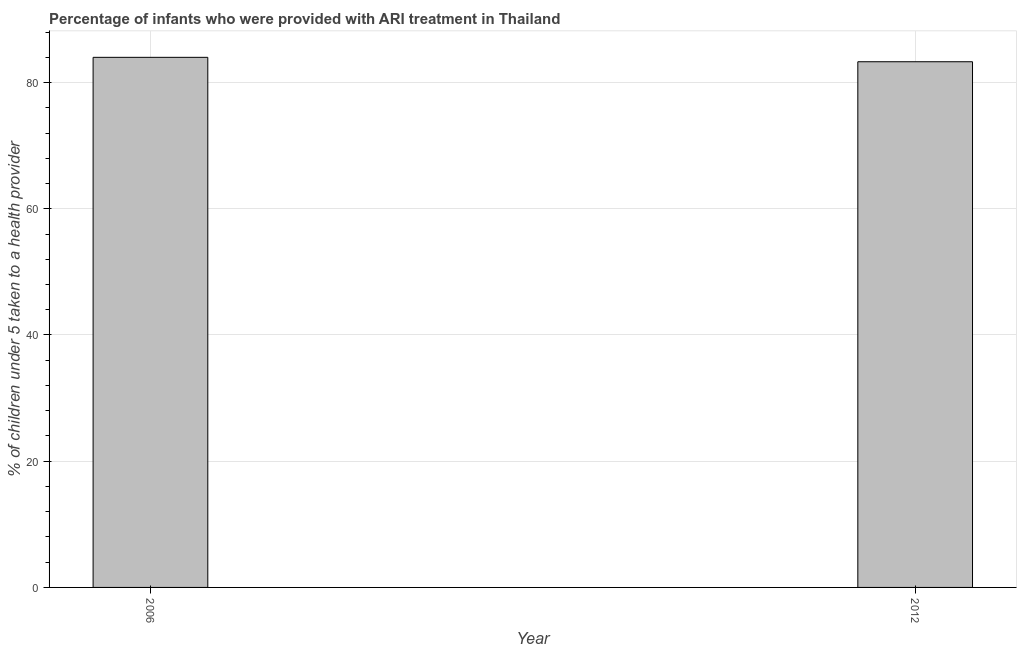Does the graph contain any zero values?
Your response must be concise. No. What is the title of the graph?
Offer a very short reply. Percentage of infants who were provided with ARI treatment in Thailand. What is the label or title of the X-axis?
Your response must be concise. Year. What is the label or title of the Y-axis?
Offer a very short reply. % of children under 5 taken to a health provider. What is the percentage of children who were provided with ari treatment in 2012?
Offer a very short reply. 83.3. Across all years, what is the maximum percentage of children who were provided with ari treatment?
Your response must be concise. 84. Across all years, what is the minimum percentage of children who were provided with ari treatment?
Ensure brevity in your answer.  83.3. In which year was the percentage of children who were provided with ari treatment maximum?
Your answer should be very brief. 2006. What is the sum of the percentage of children who were provided with ari treatment?
Offer a very short reply. 167.3. What is the difference between the percentage of children who were provided with ari treatment in 2006 and 2012?
Provide a short and direct response. 0.7. What is the average percentage of children who were provided with ari treatment per year?
Give a very brief answer. 83.65. What is the median percentage of children who were provided with ari treatment?
Offer a terse response. 83.65. What is the ratio of the percentage of children who were provided with ari treatment in 2006 to that in 2012?
Provide a short and direct response. 1.01. Is the percentage of children who were provided with ari treatment in 2006 less than that in 2012?
Your response must be concise. No. In how many years, is the percentage of children who were provided with ari treatment greater than the average percentage of children who were provided with ari treatment taken over all years?
Give a very brief answer. 1. How many bars are there?
Your response must be concise. 2. What is the difference between two consecutive major ticks on the Y-axis?
Your answer should be very brief. 20. Are the values on the major ticks of Y-axis written in scientific E-notation?
Keep it short and to the point. No. What is the % of children under 5 taken to a health provider in 2006?
Your answer should be compact. 84. What is the % of children under 5 taken to a health provider in 2012?
Offer a terse response. 83.3. What is the ratio of the % of children under 5 taken to a health provider in 2006 to that in 2012?
Keep it short and to the point. 1.01. 